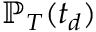<formula> <loc_0><loc_0><loc_500><loc_500>\mathbb { P } _ { T } ( t _ { d } )</formula> 